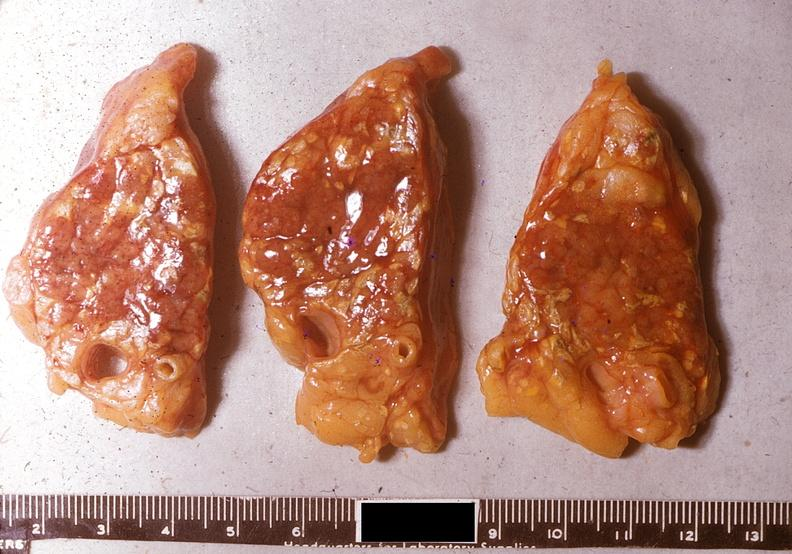does this image show acute pancreatitis?
Answer the question using a single word or phrase. Yes 